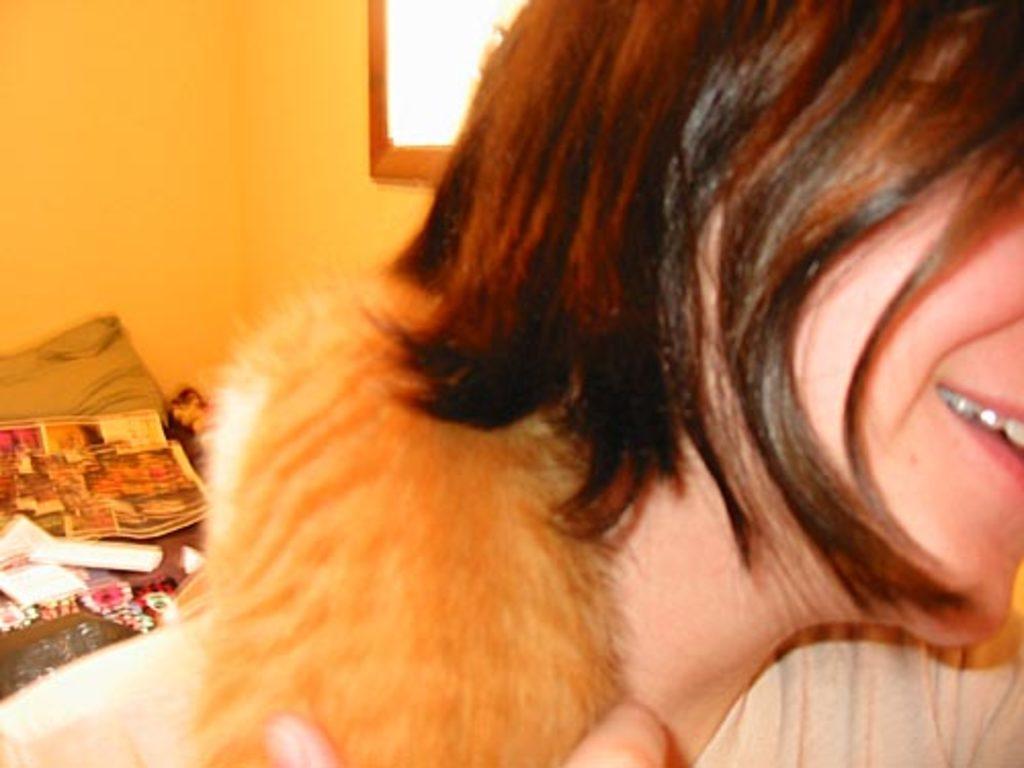Describe this image in one or two sentences. In this picture we can see a person, here we can see posters, pillow and some objects and in the background we can see a wall, mirror. 